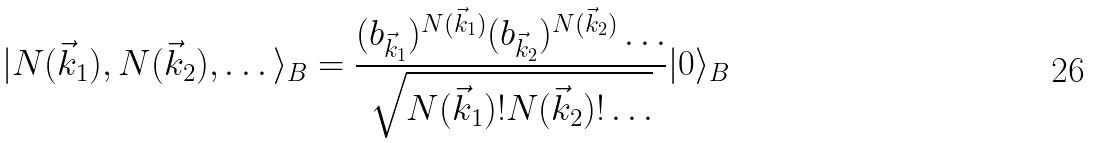<formula> <loc_0><loc_0><loc_500><loc_500>| N ( \vec { k } _ { 1 } ) , N ( \vec { k } _ { 2 } ) , \dots \rangle _ { B } = \frac { ( b _ { \vec { k } _ { 1 } } ) ^ { N ( \vec { k } _ { 1 } ) } ( b _ { \vec { k } _ { 2 } } ) ^ { N ( \vec { k } _ { 2 } ) } \dots } { \sqrt { N ( \vec { k } _ { 1 } ) ! N ( \vec { k } _ { 2 } ) ! \dots } } | 0 \rangle _ { B }</formula> 